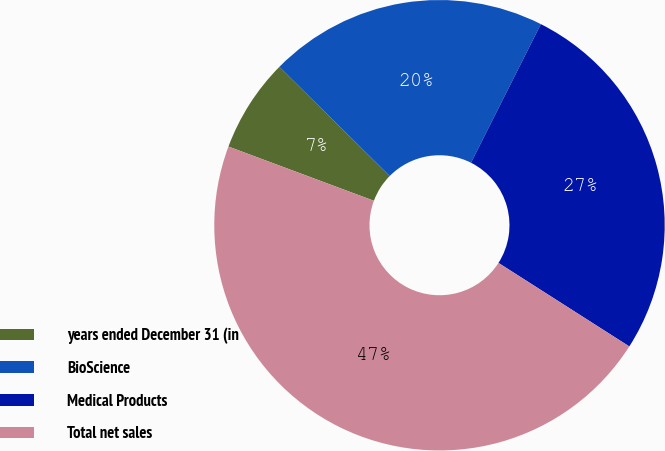<chart> <loc_0><loc_0><loc_500><loc_500><pie_chart><fcel>years ended December 31 (in<fcel>BioScience<fcel>Medical Products<fcel>Total net sales<nl><fcel>6.73%<fcel>20.02%<fcel>26.61%<fcel>46.63%<nl></chart> 